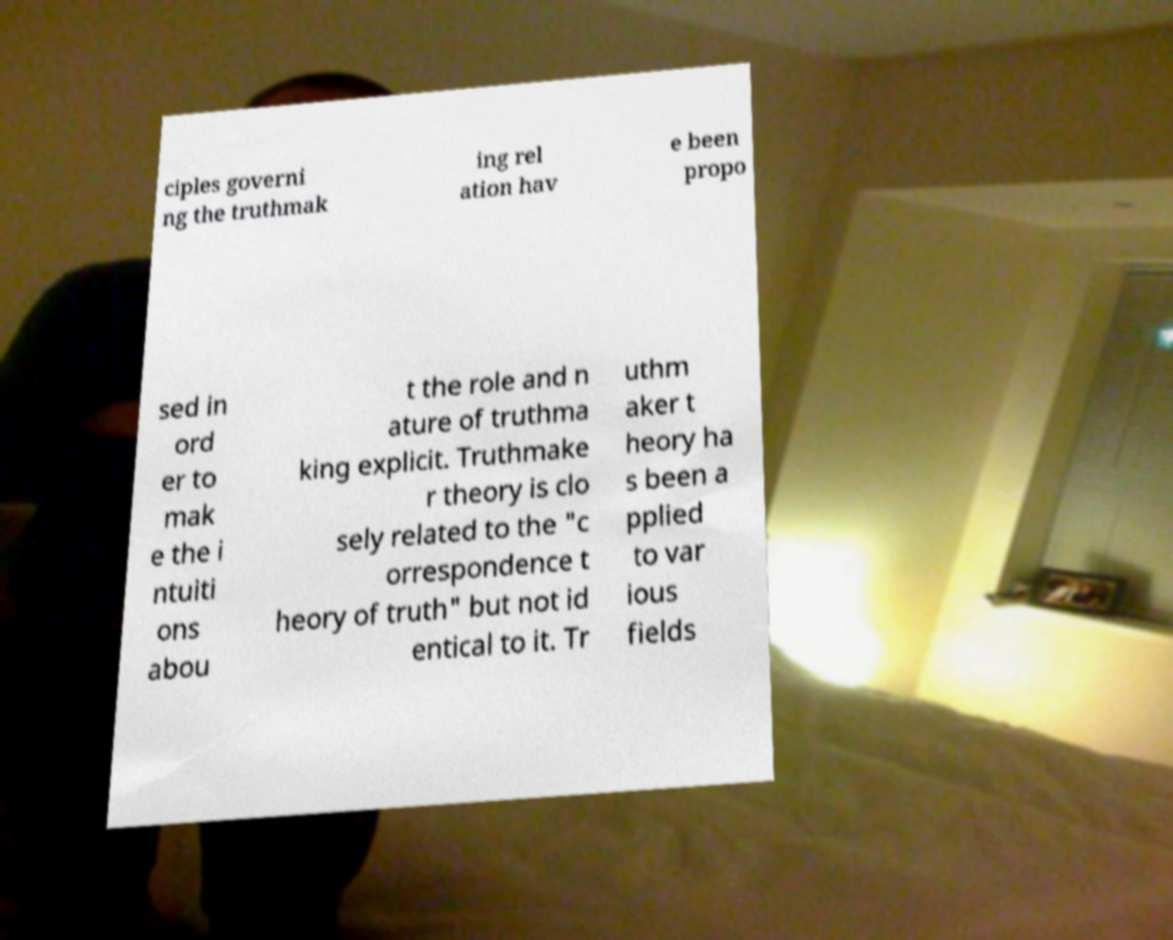Can you read and provide the text displayed in the image?This photo seems to have some interesting text. Can you extract and type it out for me? ciples governi ng the truthmak ing rel ation hav e been propo sed in ord er to mak e the i ntuiti ons abou t the role and n ature of truthma king explicit. Truthmake r theory is clo sely related to the "c orrespondence t heory of truth" but not id entical to it. Tr uthm aker t heory ha s been a pplied to var ious fields 